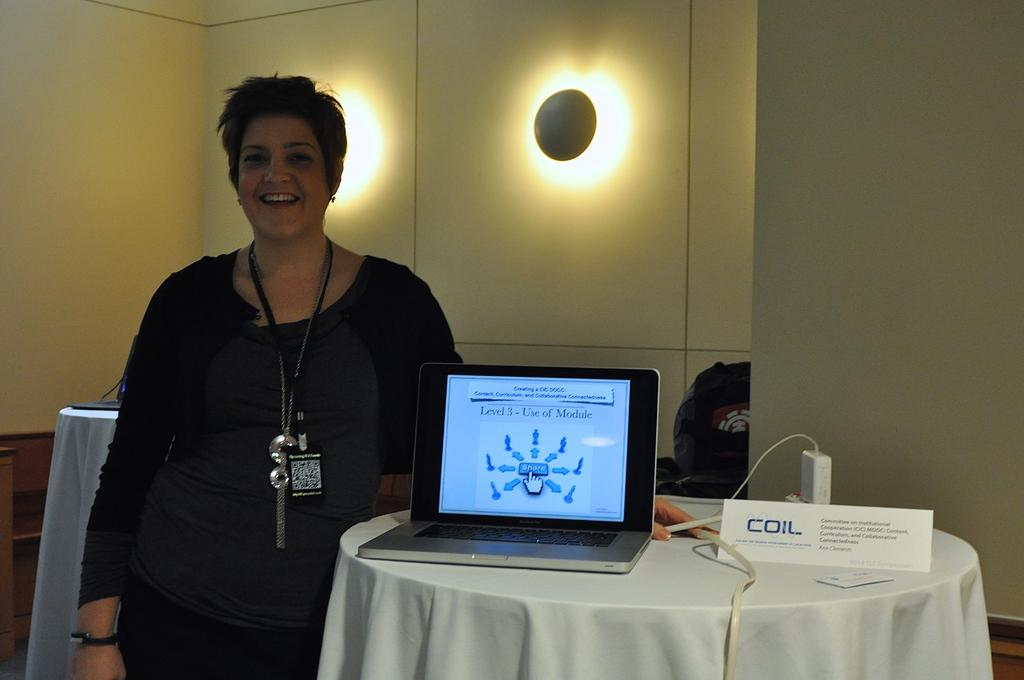What is the main subject of the image? There is a person in the image. How is the person's expression in the image? The person is smiling. What piece of furniture is present in the image? There is a table in the image. What electronic device is on the table? There is a laptop on the table. What type of skirt is the person wearing in the image? There is no skirt visible in the image; the person is not wearing one. What sound can be heard coming from the laptop in the image? The image is static, and there is no sound present. 